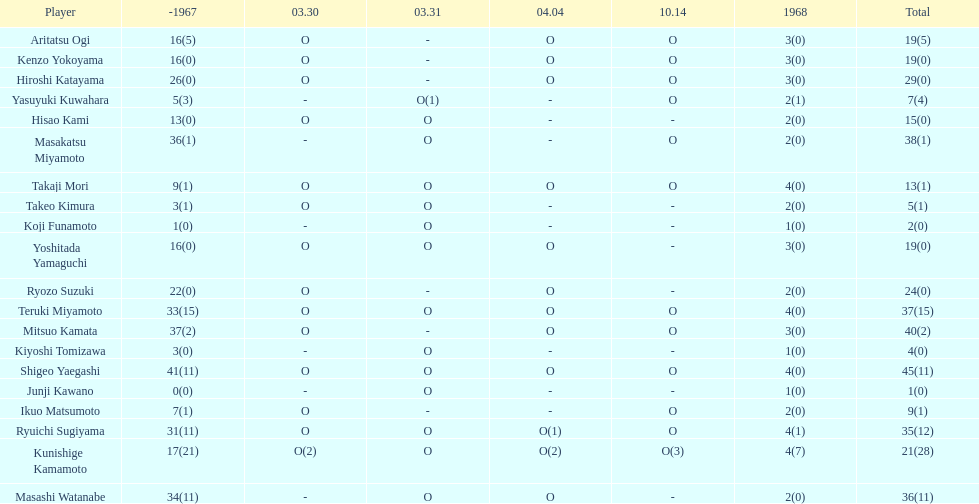Total appearances by masakatsu miyamoto? 38. 